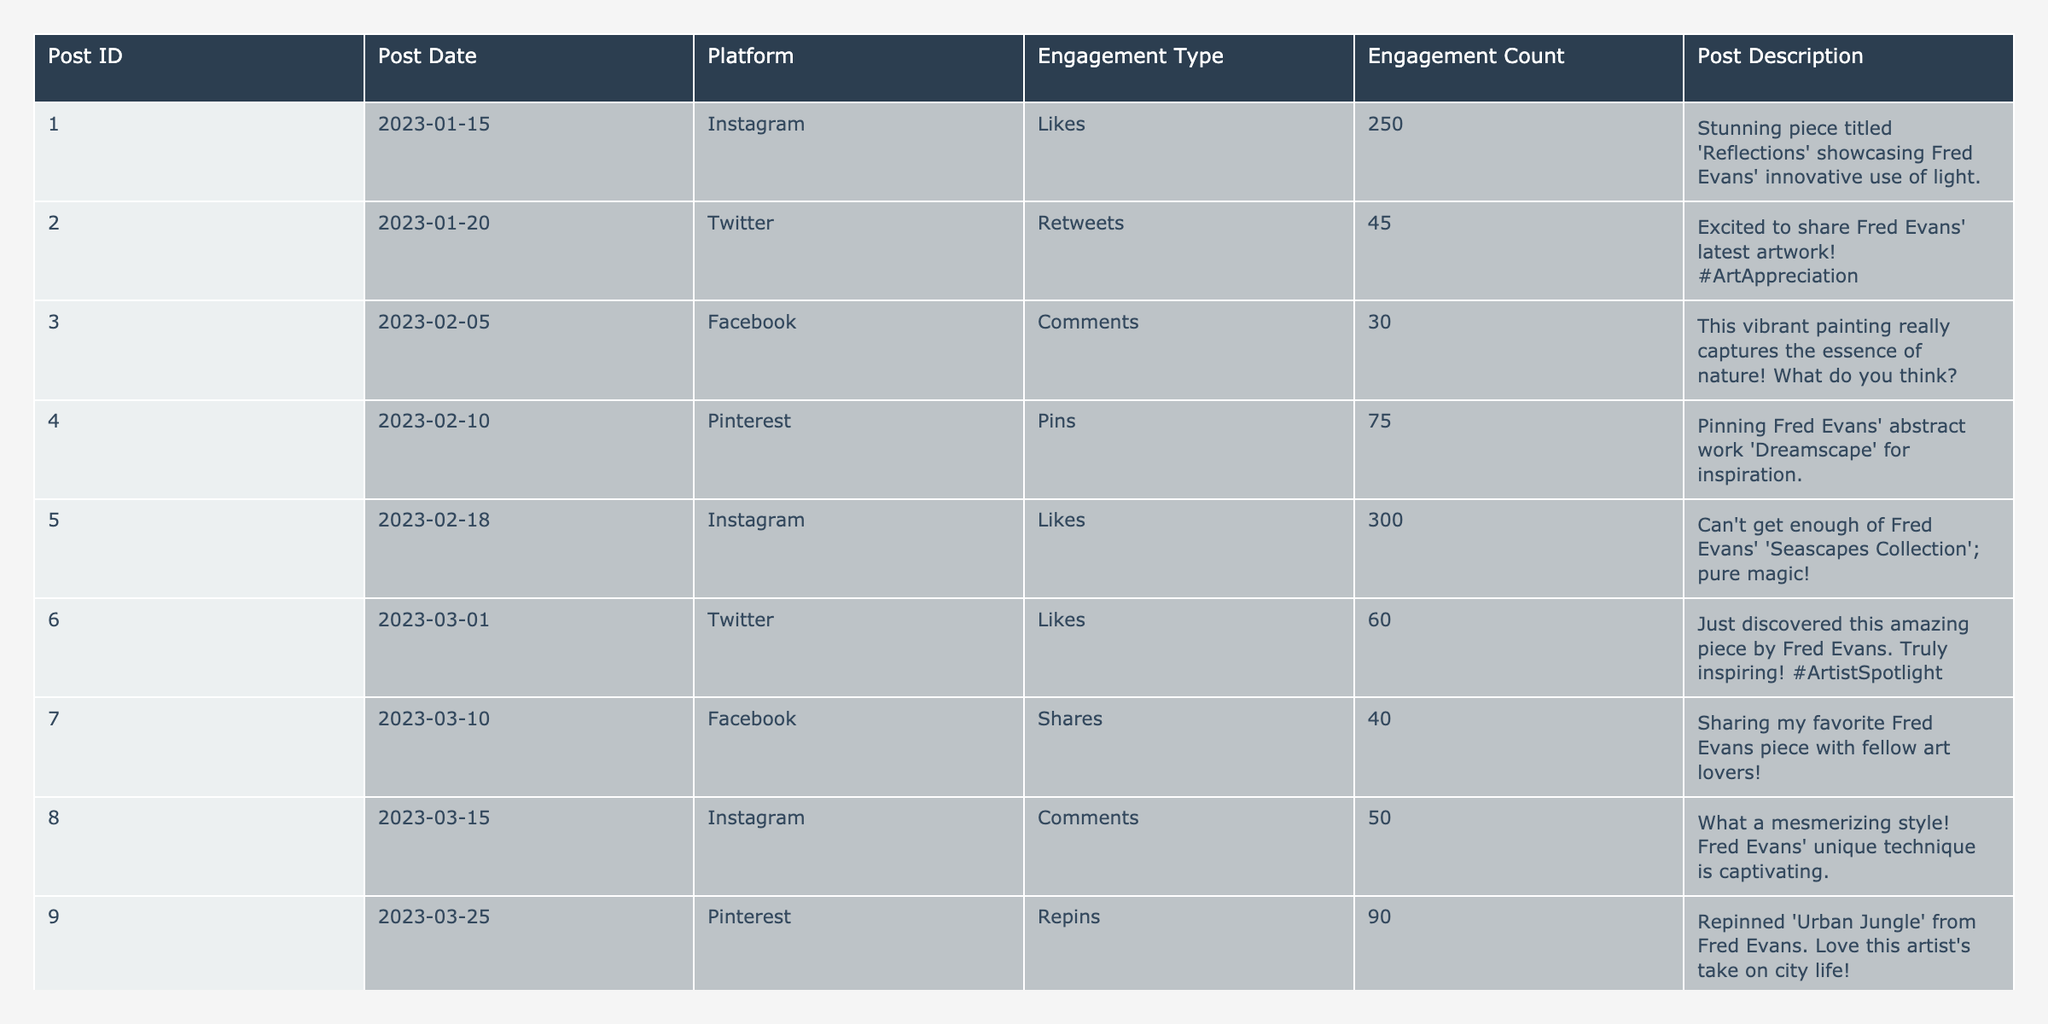What is the total engagement count for Instagram posts? We first identify all the Instagram posts in the table: Posts 001, 005, and 008. Their engagement counts are 250, 300, and 50 respectively. Now, we sum these counts: 250 + 300 + 50 = 600.
Answer: 600 Which platform had the highest number of engagement counts across all posts? We assess the engagement counts for each platform: Instagram has 600, Twitter has 125 (45 + 60 + 80), Facebook has 70 (30 + 40), and Pinterest has 165 (75 + 90). The highest is Instagram with 600.
Answer: Instagram How many retweets did Fred Evans' posts receive? Retweets are found only in Post 002, where it states 45 retweets.
Answer: 45 What is the average engagement count for all posts? We sum up all engagement counts: 250 + 45 + 30 + 75 + 300 + 60 + 40 + 50 + 90 + 80 = 1020. There are 10 posts, so we divide 1020 by 10: 1020/10 = 102.
Answer: 102 Did any post receive more than 300 likes? We look for the likes in the Instagram posts: Post 001 has 250 likes, and Post 005 has 300 likes. Since no post exceeds 300 likes, the answer is no.
Answer: No Which engagement type received the least interaction? We compare the engagement counts of each type. Comments: 30, Retweets: 45, Shares: 40, Pins: 75, Likes: 250 + 300 + 60 + 80 = 690, and Repins: 90. The lowest is Comments with 30.
Answer: Comments What is the engagement count difference between the Twitter likes and engagement counts on Facebook? On Twitter, likes total 60 + 80 = 140. On Facebook, total engagement is 30 (comments) + 40 (shares) = 70. The difference is 140 - 70 = 70.
Answer: 70 Which post had the highest engagement count and what was the count? The analysis shows that Post 005 has the highest engagement with 300 likes.
Answer: Post 005, 300 How many total comments are there across all platforms? The only comments are in Post 003 on Facebook with 30 comments. There are no comments on other posts.
Answer: 30 Which post has the most engagement and what is its description? Post 005 has the highest engagement count of 300 with the description: "Can't get enough of Fred Evans' 'Seascapes Collection'; pure magic!"
Answer: Post 005, “Can't get enough..." 